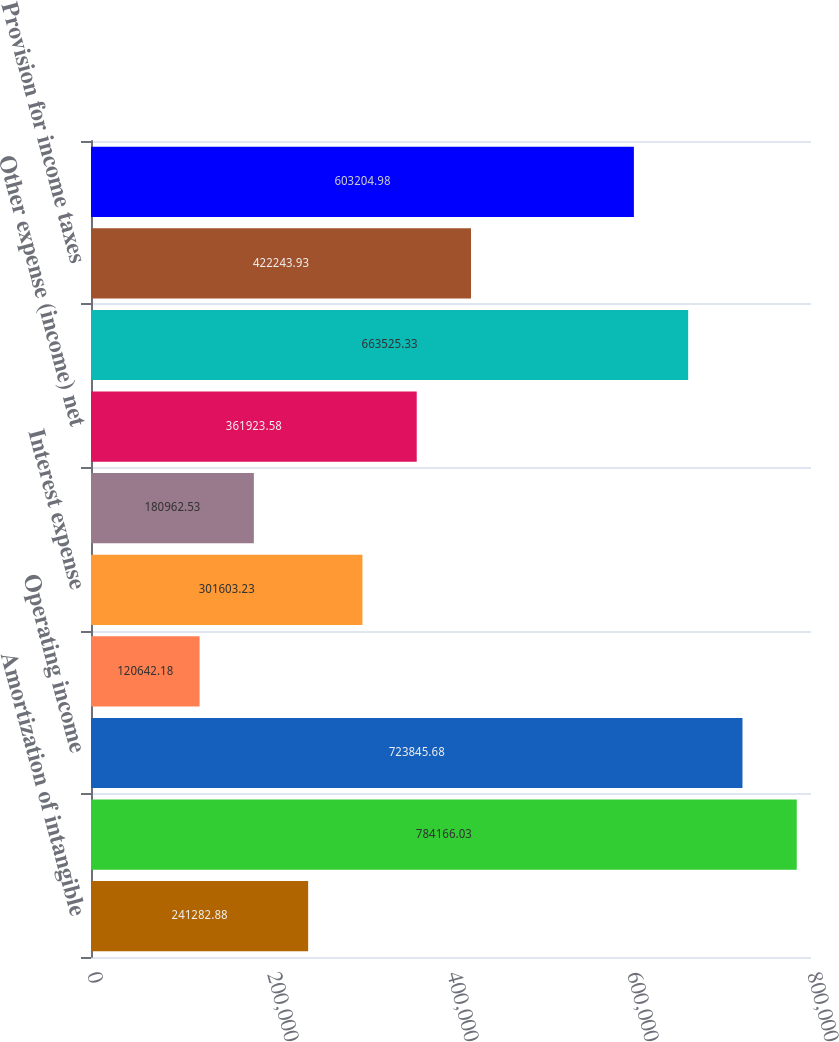Convert chart. <chart><loc_0><loc_0><loc_500><loc_500><bar_chart><fcel>Amortization of intangible<fcel>Total operating expenses<fcel>Operating income<fcel>Interest income<fcel>Interest expense<fcel>Other expense<fcel>Other expense (income) net<fcel>Income before provision for<fcel>Provision for income taxes<fcel>Net income<nl><fcel>241283<fcel>784166<fcel>723846<fcel>120642<fcel>301603<fcel>180963<fcel>361924<fcel>663525<fcel>422244<fcel>603205<nl></chart> 